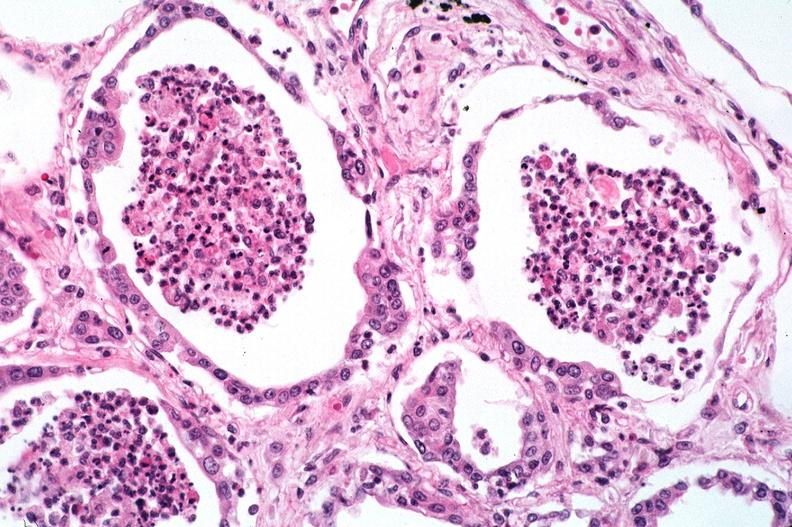what is present?
Answer the question using a single word or phrase. Respiratory 